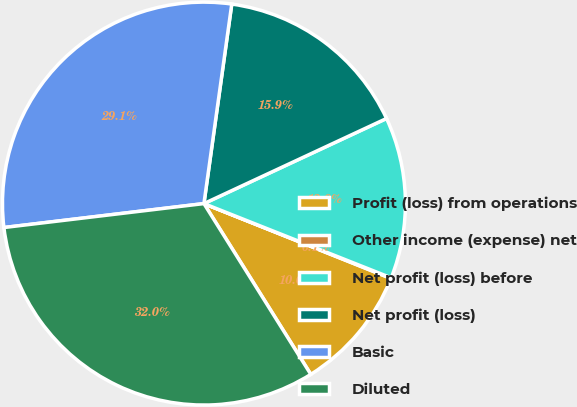Convert chart to OTSL. <chart><loc_0><loc_0><loc_500><loc_500><pie_chart><fcel>Profit (loss) from operations<fcel>Other income (expense) net<fcel>Net profit (loss) before<fcel>Net profit (loss)<fcel>Basic<fcel>Diluted<nl><fcel>10.04%<fcel>0.05%<fcel>12.95%<fcel>15.85%<fcel>29.1%<fcel>32.0%<nl></chart> 